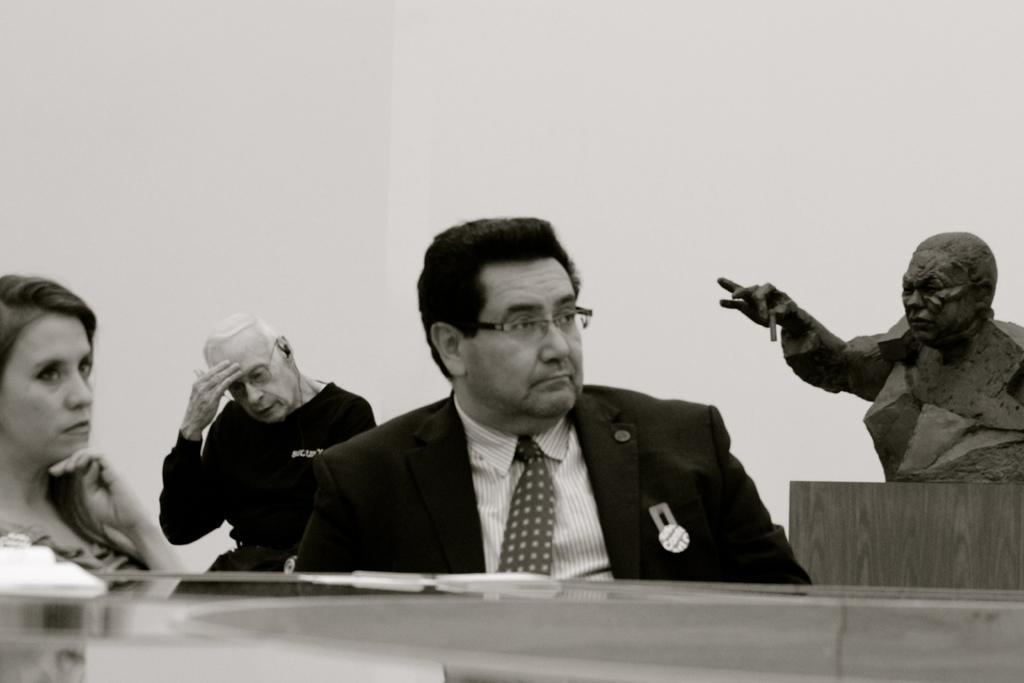Describe this image in one or two sentences. In the middle of an image there is a man sitting on the chair. He is wearing a tie,shirt and coat. Behind him there is a man sitting and left side of an image there is a woman. Right side of an image there is a statue. 